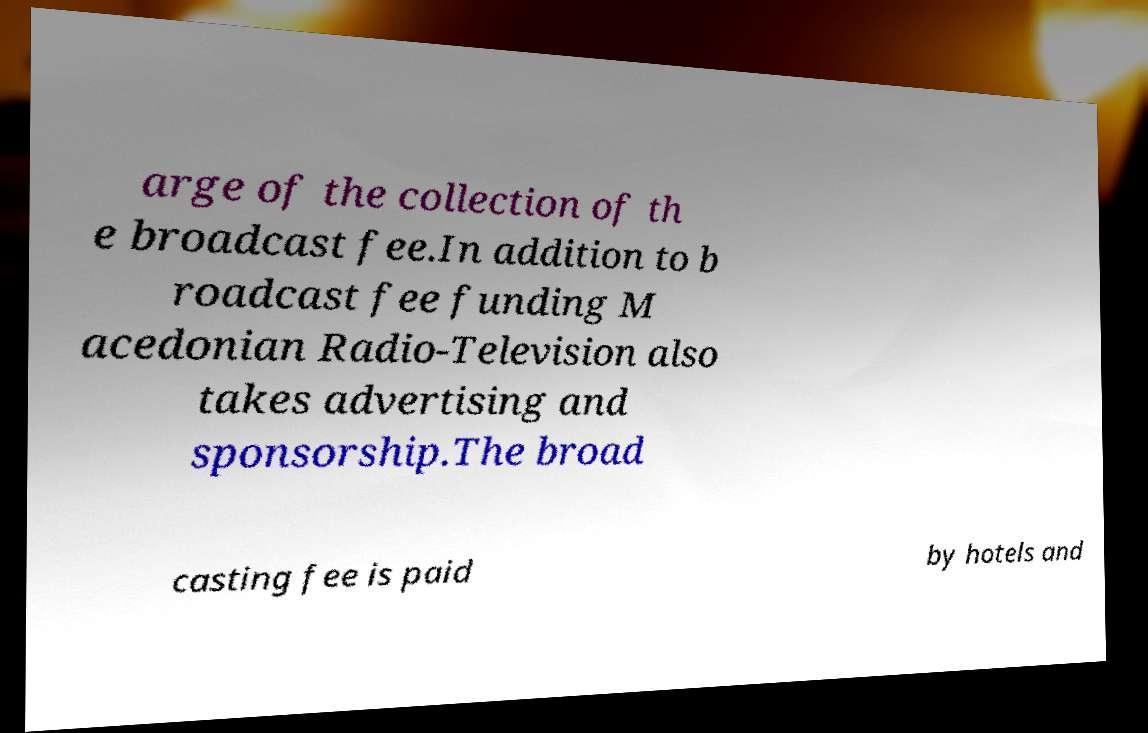There's text embedded in this image that I need extracted. Can you transcribe it verbatim? arge of the collection of th e broadcast fee.In addition to b roadcast fee funding M acedonian Radio-Television also takes advertising and sponsorship.The broad casting fee is paid by hotels and 